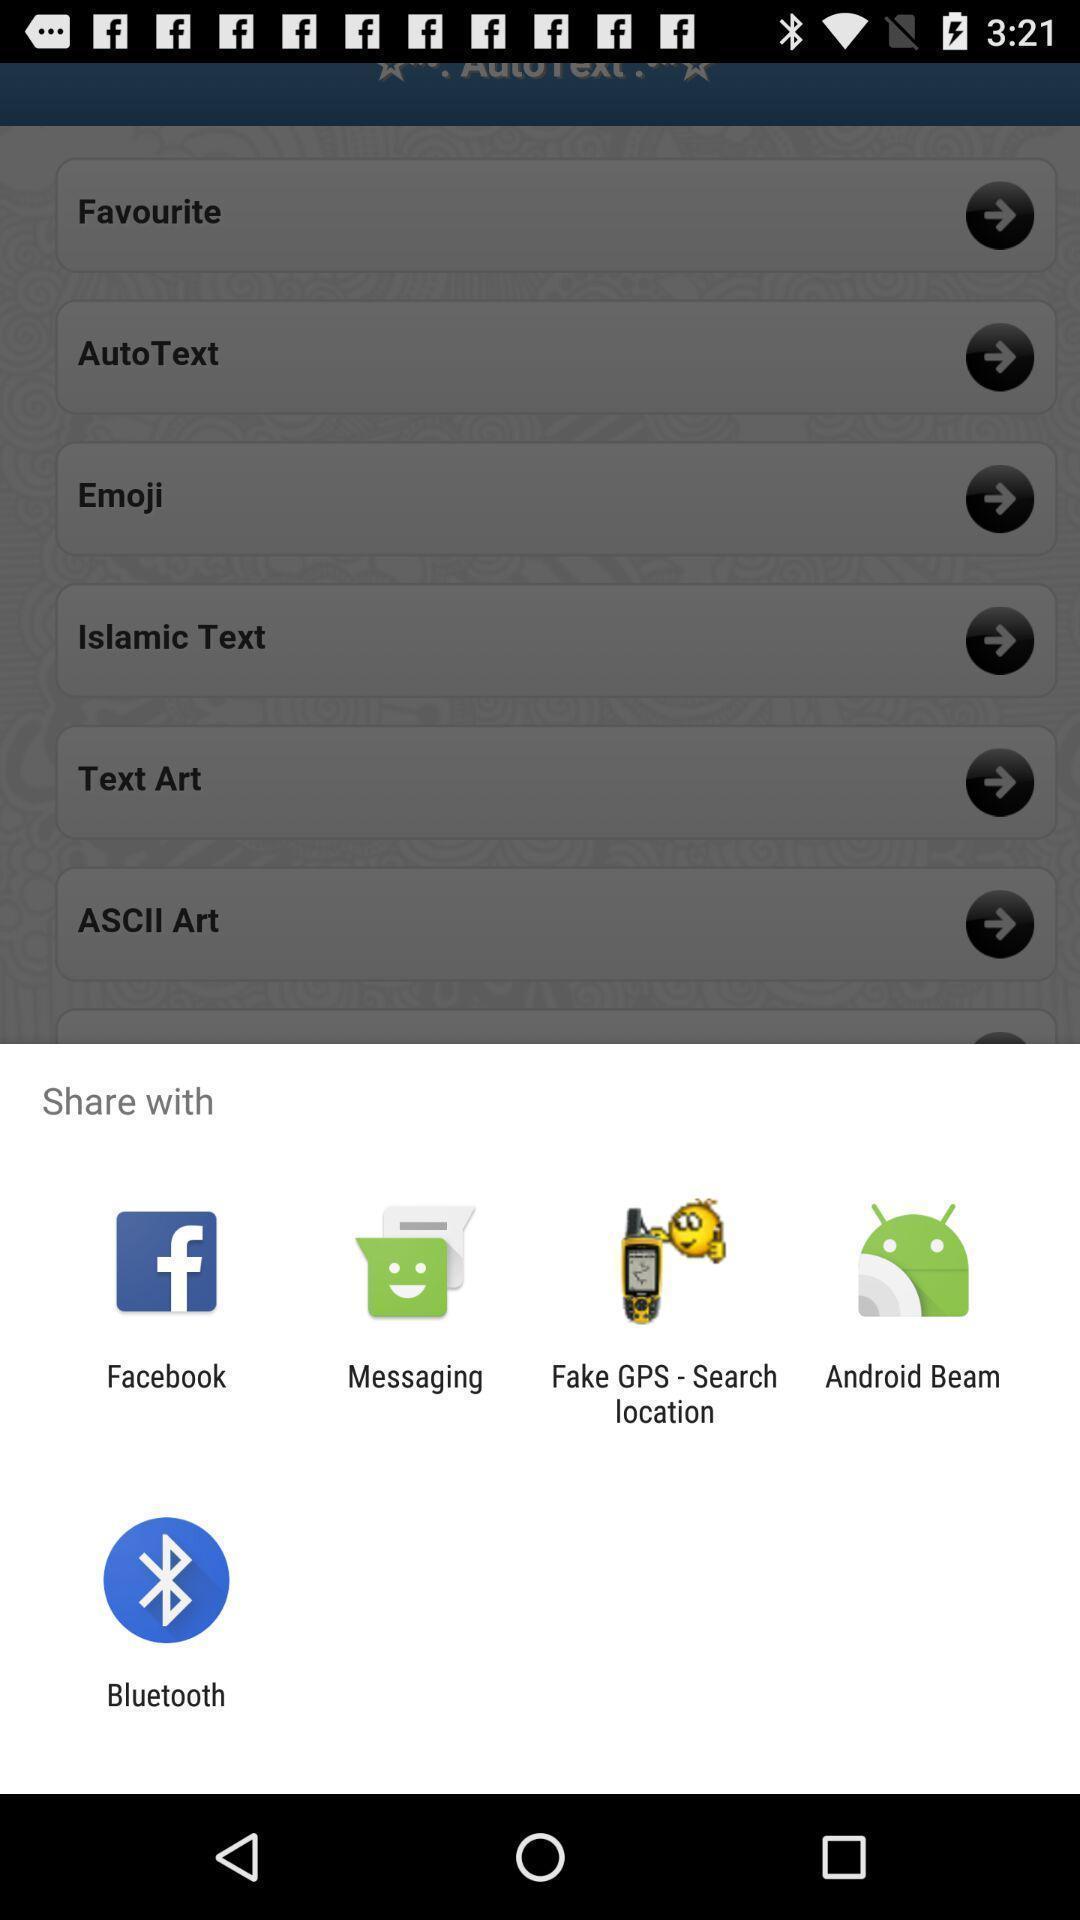Summarize the information in this screenshot. Pop-up showing different options to share content. 